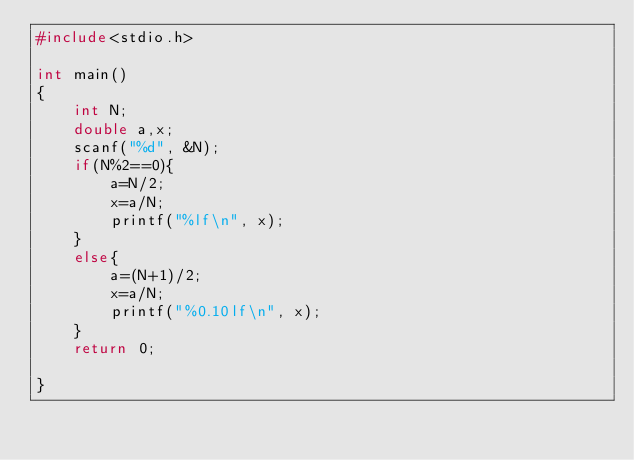<code> <loc_0><loc_0><loc_500><loc_500><_C_>#include<stdio.h>

int main()
{
    int N;
    double a,x;
    scanf("%d", &N);
    if(N%2==0){
        a=N/2;
        x=a/N;
        printf("%lf\n", x);
    }
    else{
        a=(N+1)/2;
        x=a/N;
        printf("%0.10lf\n", x);
    }
    return 0;

}
</code> 